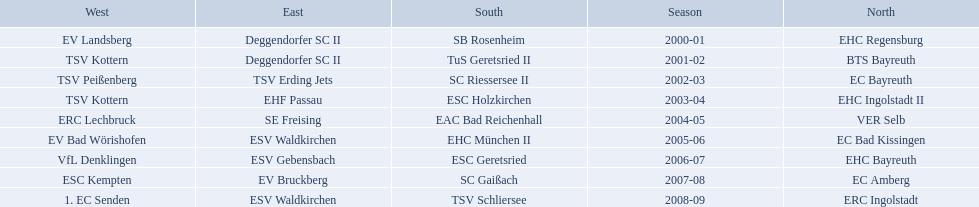Which teams played in the north? EHC Regensburg, BTS Bayreuth, EC Bayreuth, EHC Ingolstadt II, VER Selb, EC Bad Kissingen, EHC Bayreuth, EC Amberg, ERC Ingolstadt. Of these teams, which played during 2000-2001? EHC Regensburg. 